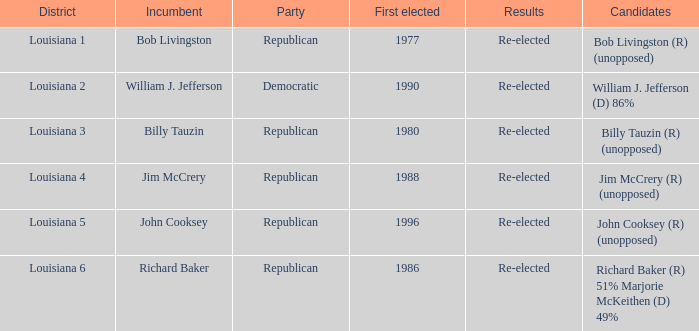What district does John Cooksey represent? Louisiana 5. 